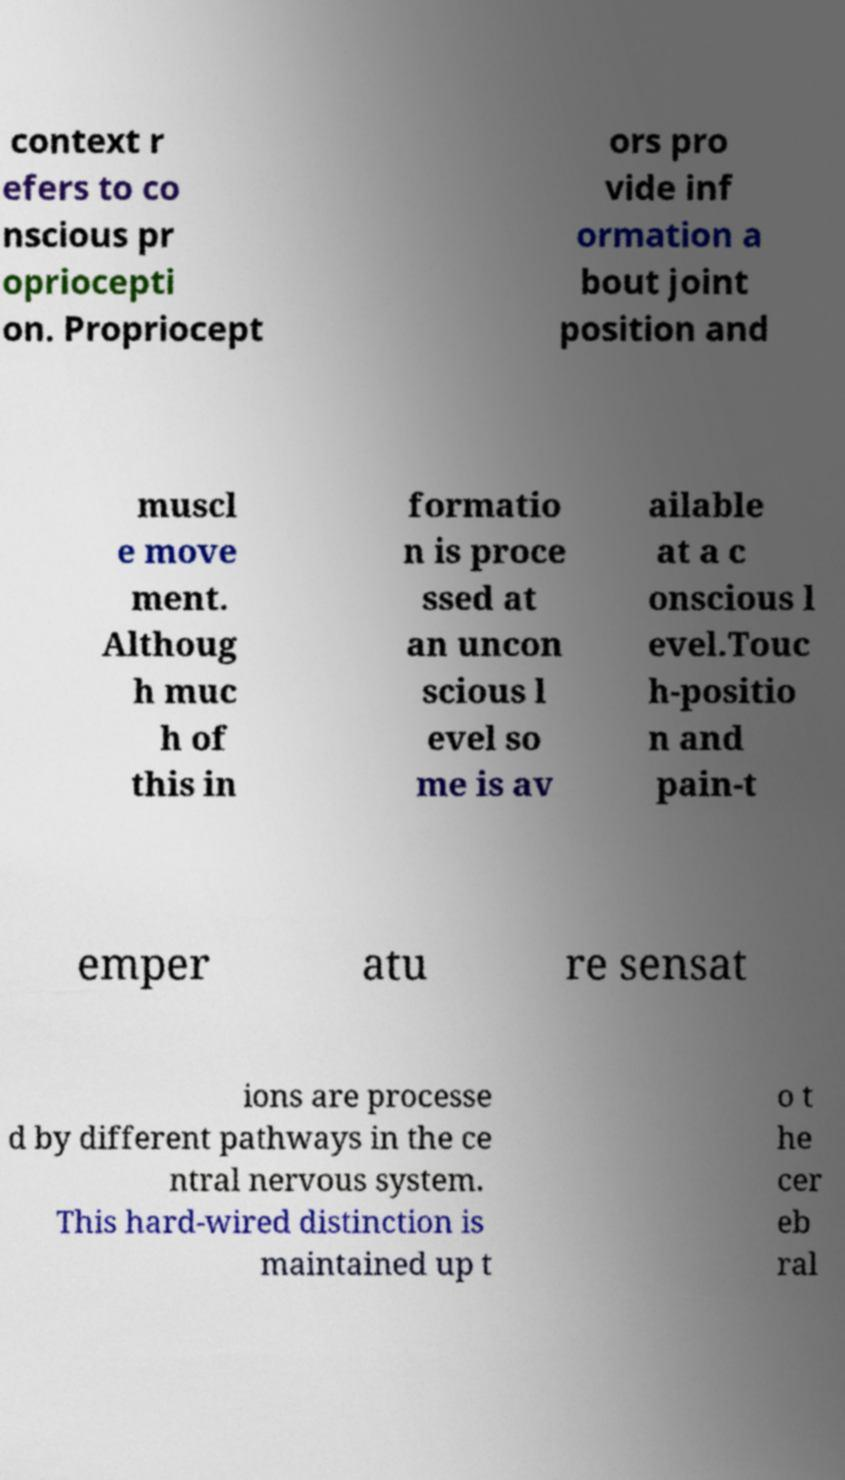Could you assist in decoding the text presented in this image and type it out clearly? context r efers to co nscious pr opriocepti on. Propriocept ors pro vide inf ormation a bout joint position and muscl e move ment. Althoug h muc h of this in formatio n is proce ssed at an uncon scious l evel so me is av ailable at a c onscious l evel.Touc h-positio n and pain-t emper atu re sensat ions are processe d by different pathways in the ce ntral nervous system. This hard-wired distinction is maintained up t o t he cer eb ral 